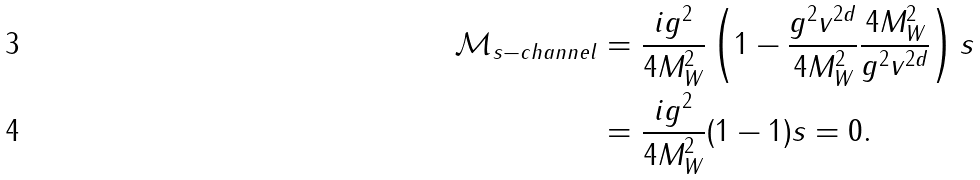<formula> <loc_0><loc_0><loc_500><loc_500>\mathcal { M } _ { s - c h a n n e l } & = \frac { i g ^ { 2 } } { 4 M _ { W } ^ { 2 } } \left ( 1 - \frac { g ^ { 2 } v ^ { 2 d } } { 4 M _ { W } ^ { 2 } } \frac { 4 M _ { W } ^ { 2 } } { g ^ { 2 } v ^ { 2 d } } \right ) s \\ & = \frac { i g ^ { 2 } } { 4 M _ { W } ^ { 2 } } ( 1 - 1 ) s = 0 .</formula> 